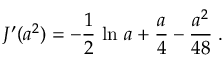<formula> <loc_0><loc_0><loc_500><loc_500>J ^ { \prime } ( a ^ { 2 } ) = - { \frac { 1 } { 2 } } \, \ln \, a + { \frac { a } { 4 } } - { \frac { a ^ { 2 } } { 4 8 } } \, .</formula> 